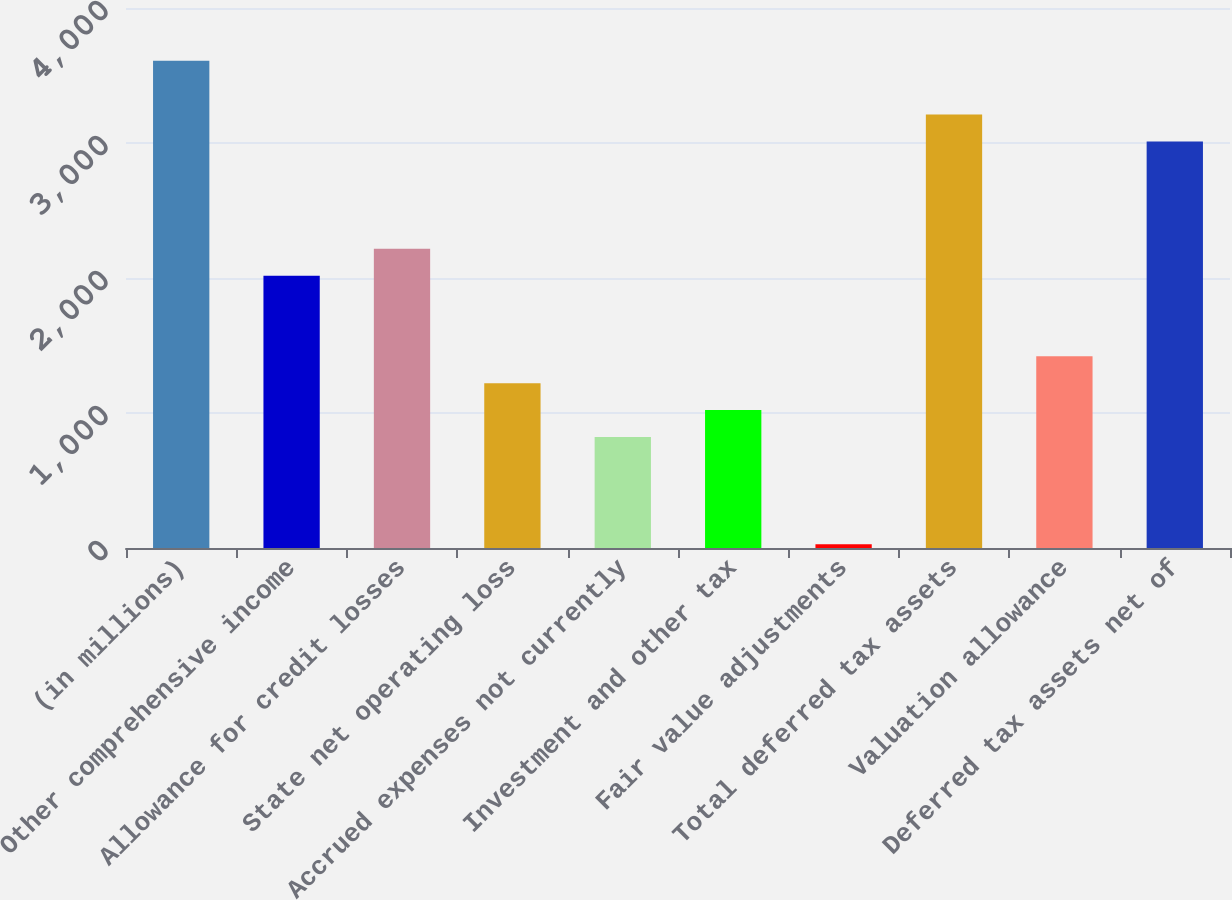<chart> <loc_0><loc_0><loc_500><loc_500><bar_chart><fcel>(in millions)<fcel>Other comprehensive income<fcel>Allowance for credit losses<fcel>State net operating loss<fcel>Accrued expenses not currently<fcel>Investment and other tax<fcel>Fair value adjustments<fcel>Total deferred tax assets<fcel>Valuation allowance<fcel>Deferred tax assets net of<nl><fcel>3609<fcel>2017<fcel>2216<fcel>1221<fcel>823<fcel>1022<fcel>27<fcel>3211<fcel>1420<fcel>3012<nl></chart> 